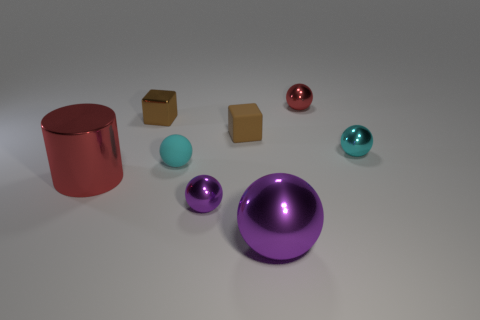Subtract all red balls. How many balls are left? 4 Subtract all cyan matte balls. How many balls are left? 4 Subtract all gray balls. Subtract all brown cylinders. How many balls are left? 5 Add 1 big gray rubber cylinders. How many objects exist? 9 Subtract all spheres. How many objects are left? 3 Subtract 0 purple blocks. How many objects are left? 8 Subtract all purple metallic things. Subtract all tiny things. How many objects are left? 0 Add 3 metallic cylinders. How many metallic cylinders are left? 4 Add 4 metal objects. How many metal objects exist? 10 